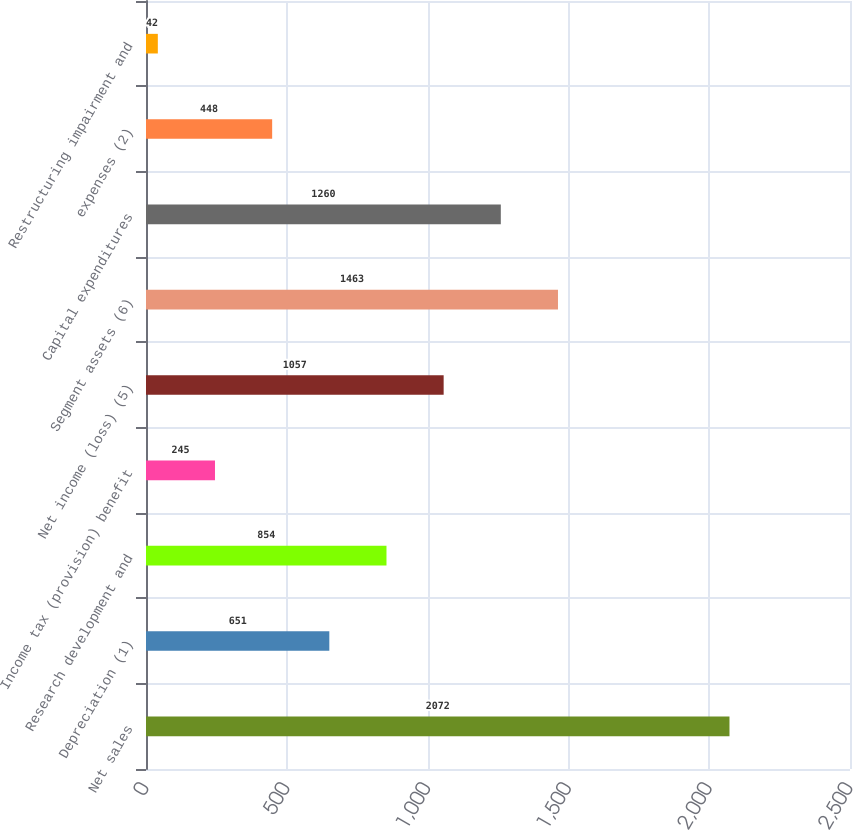Convert chart to OTSL. <chart><loc_0><loc_0><loc_500><loc_500><bar_chart><fcel>Net sales<fcel>Depreciation (1)<fcel>Research development and<fcel>Income tax (provision) benefit<fcel>Net income (loss) (5)<fcel>Segment assets (6)<fcel>Capital expenditures<fcel>expenses (2)<fcel>Restructuring impairment and<nl><fcel>2072<fcel>651<fcel>854<fcel>245<fcel>1057<fcel>1463<fcel>1260<fcel>448<fcel>42<nl></chart> 